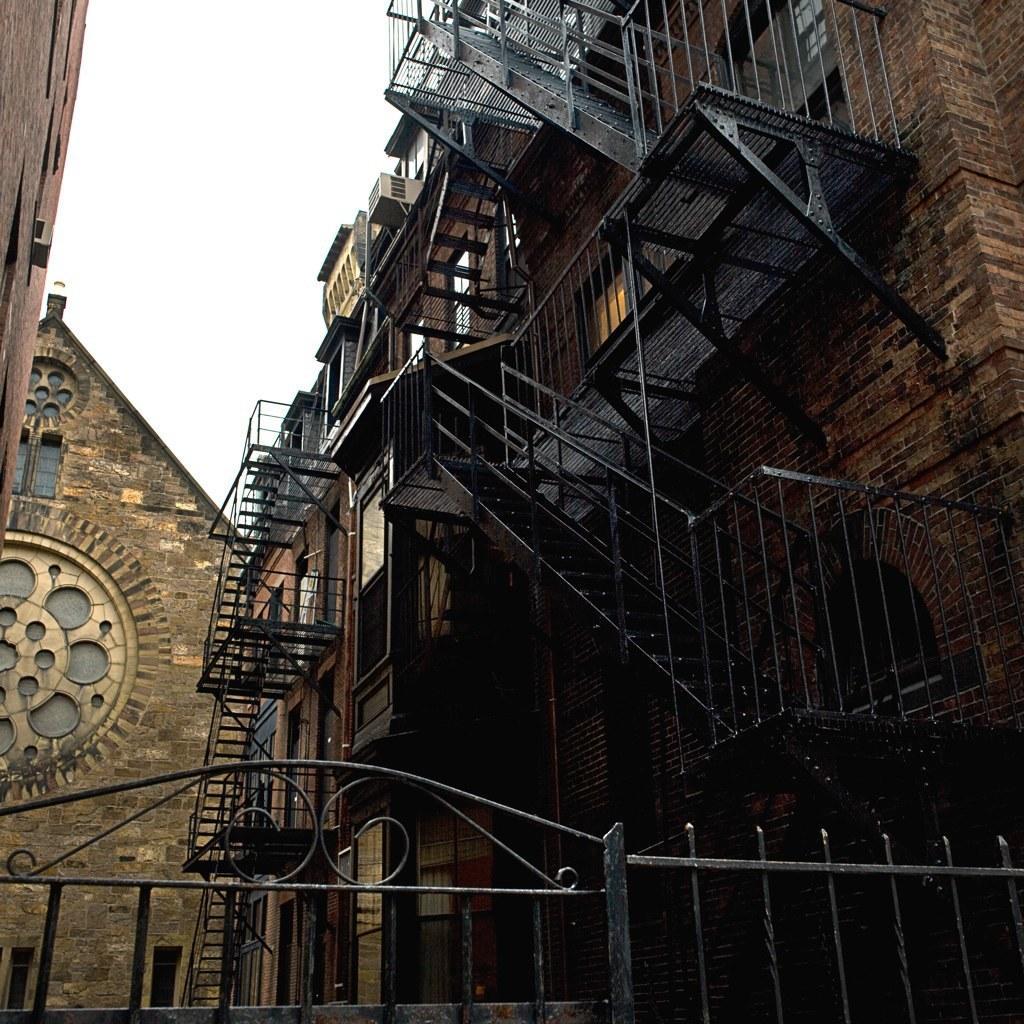In one or two sentences, can you explain what this image depicts? This image is taken outdoors. At the top of the image there is a sky. In this image there are three buildings with walls, windows, grills, railings, iron bars, balconies and carvings. 